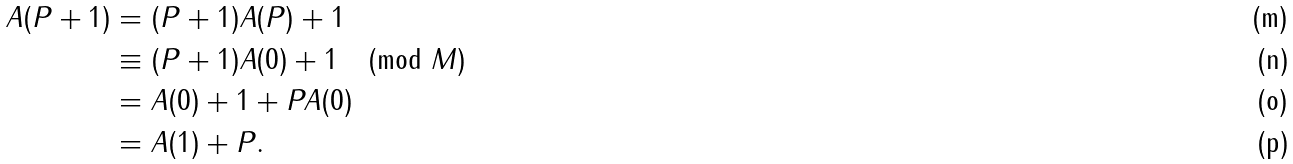<formula> <loc_0><loc_0><loc_500><loc_500>A ( P + 1 ) & = ( P + 1 ) A ( P ) + 1 \\ & \equiv ( P + 1 ) A ( 0 ) + 1 \pmod { M } \\ & = A ( 0 ) + 1 + P A ( 0 ) \\ & = A ( 1 ) + P .</formula> 